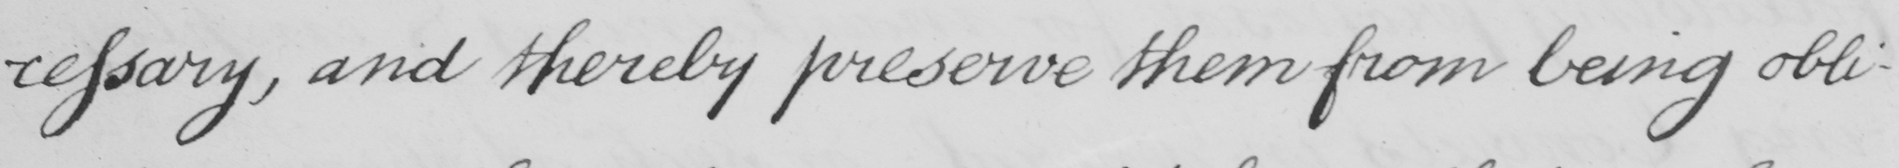Can you tell me what this handwritten text says? -cessary, and thereby preserve them from being obli- 